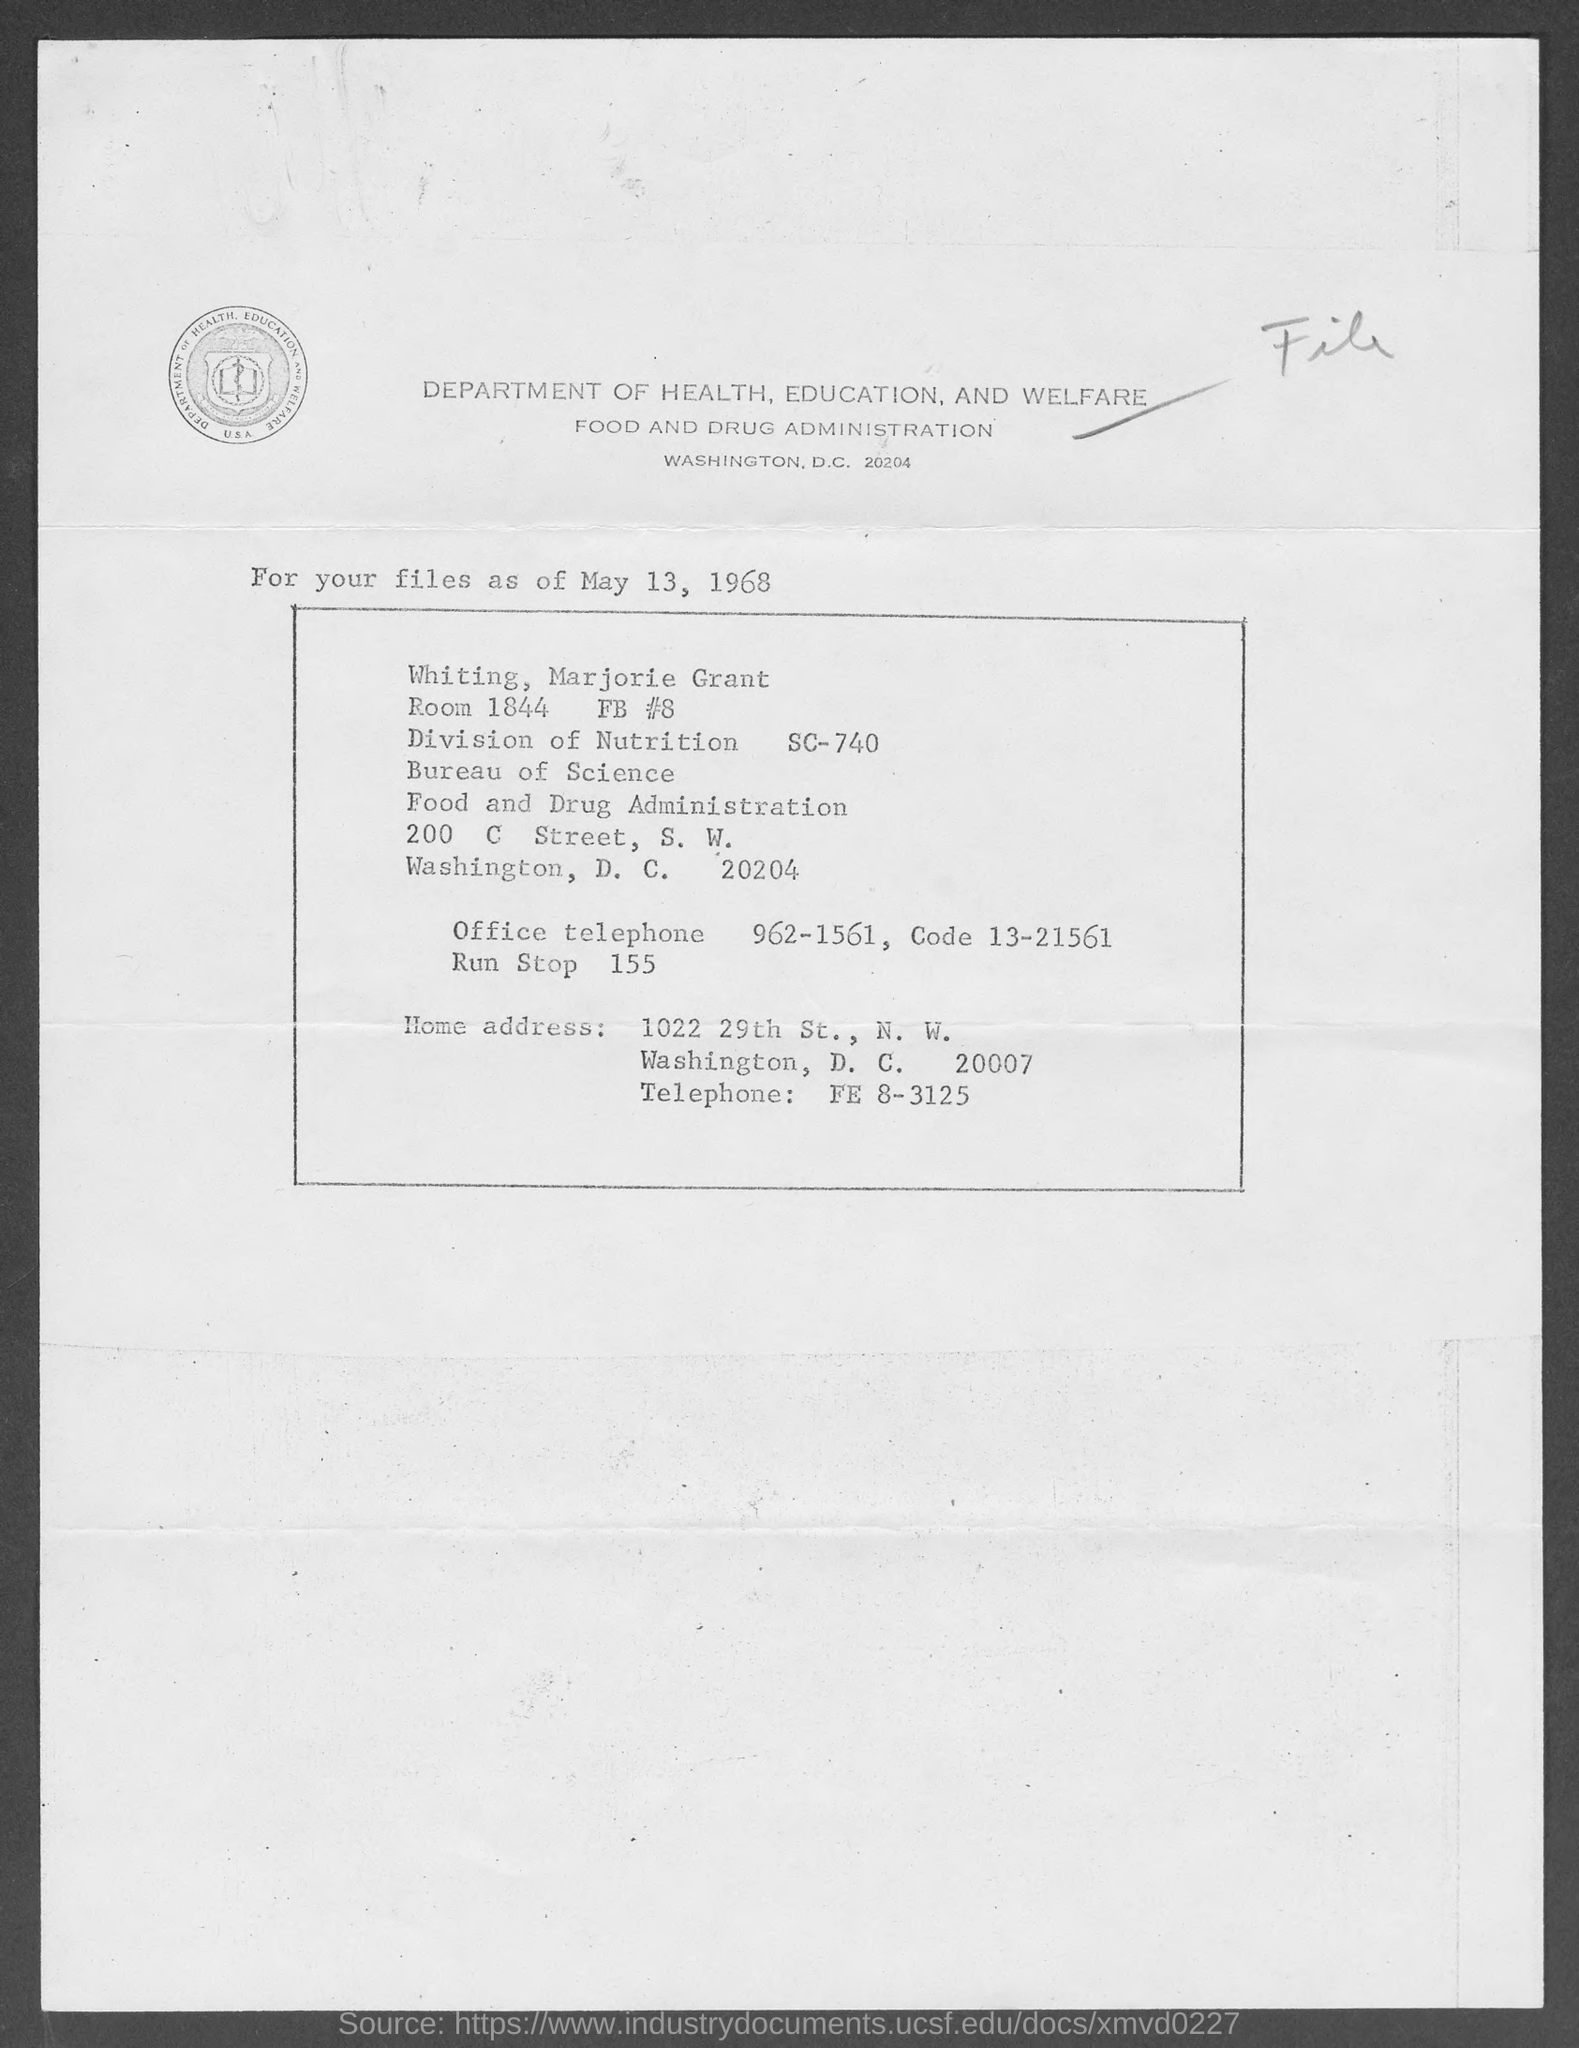Highlight a few significant elements in this photo. The date on the document is May 13, 1968. The room number is 1844. The office telephone number is 962-1561. 